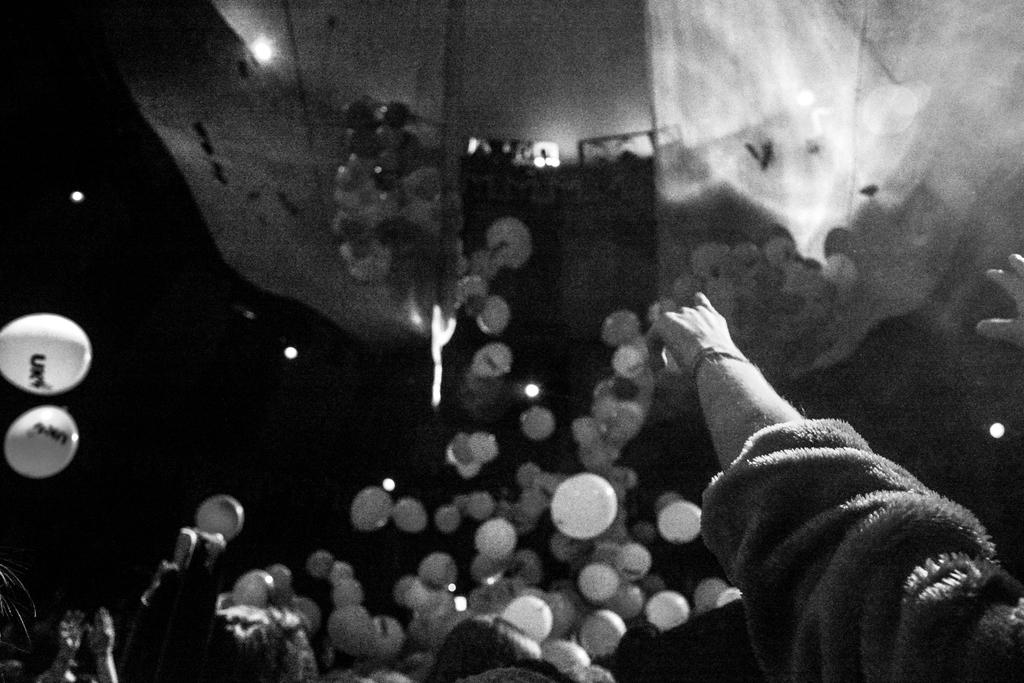What can be seen in the image involving multiple persons? There are hands of multiple persons in the image. What objects are in front of the hands? There are balloons in front of the hands. What type of food can be seen in the hands of the persons in the image? There is no food visible in the hands of the persons in the image; only balloons are present. Can you see any cats interacting with the balloons in the image? There are no cats present in the image. 